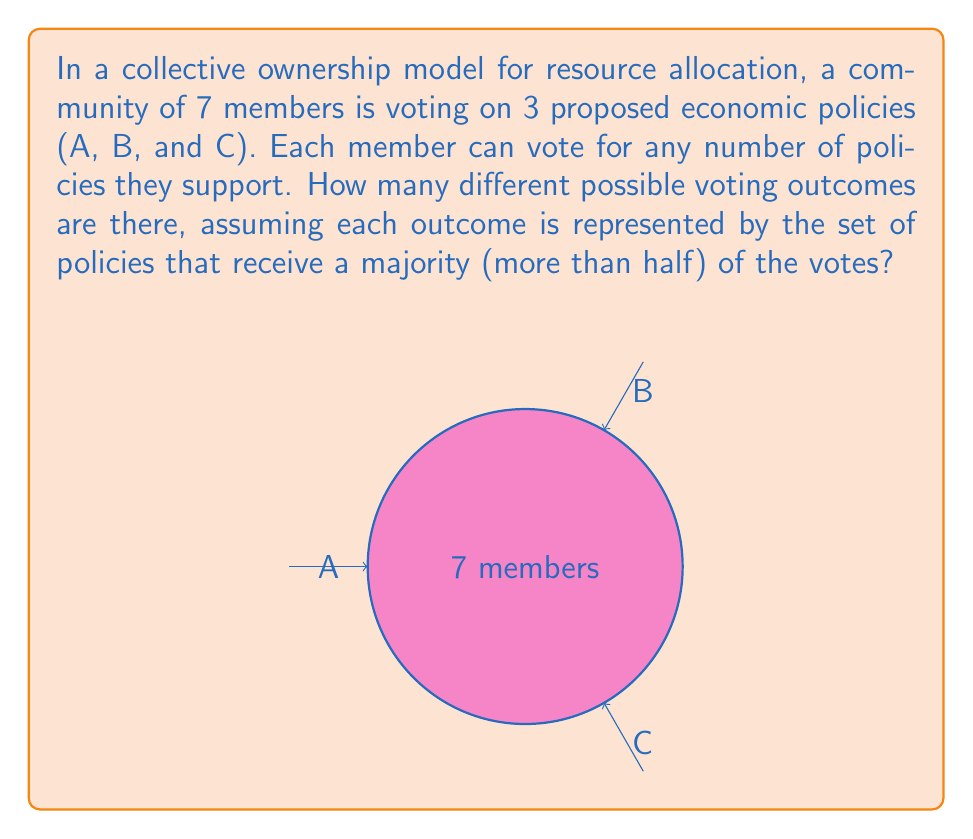Show me your answer to this math problem. Let's approach this step-by-step:

1) First, we need to understand what constitutes a majority in this case:
   With 7 members, a majority is achieved with 4 or more votes.

2) Now, let's consider the possible outcomes for each policy:
   - It can receive 0 to 3 votes (not passing)
   - It can receive 4 to 7 votes (passing)

3) We're interested in the combinations of policies that pass. Let's enumerate the possibilities:
   - No policies pass
   - Only A passes
   - Only B passes
   - Only C passes
   - A and B pass
   - A and C pass
   - B and C pass
   - All three (A, B, and C) pass

4) To confirm this, let's use the combination formula:
   $$\sum_{k=0}^3 \binom{3}{k} = \binom{3}{0} + \binom{3}{1} + \binom{3}{2} + \binom{3}{3} = 1 + 3 + 3 + 1 = 8$$

5) This tells us that there are indeed 8 possible combinations of policies passing or not passing.

6) Each of these 8 outcomes represents a unique set of policies that receive a majority of votes, regardless of the exact vote count for each policy.

Therefore, there are 8 different possible voting outcomes in terms of which policies pass by majority.
Answer: 8 possible outcomes 